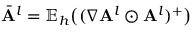<formula> <loc_0><loc_0><loc_500><loc_500>\bar { A } ^ { l } = \mathbb { E } _ { h } \left ( ( \nabla A ^ { l } \odot A ^ { l } ) ^ { + } \right )</formula> 